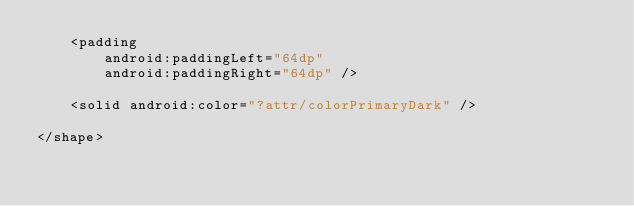Convert code to text. <code><loc_0><loc_0><loc_500><loc_500><_XML_>    <padding
        android:paddingLeft="64dp"
        android:paddingRight="64dp" />

    <solid android:color="?attr/colorPrimaryDark" />

</shape></code> 